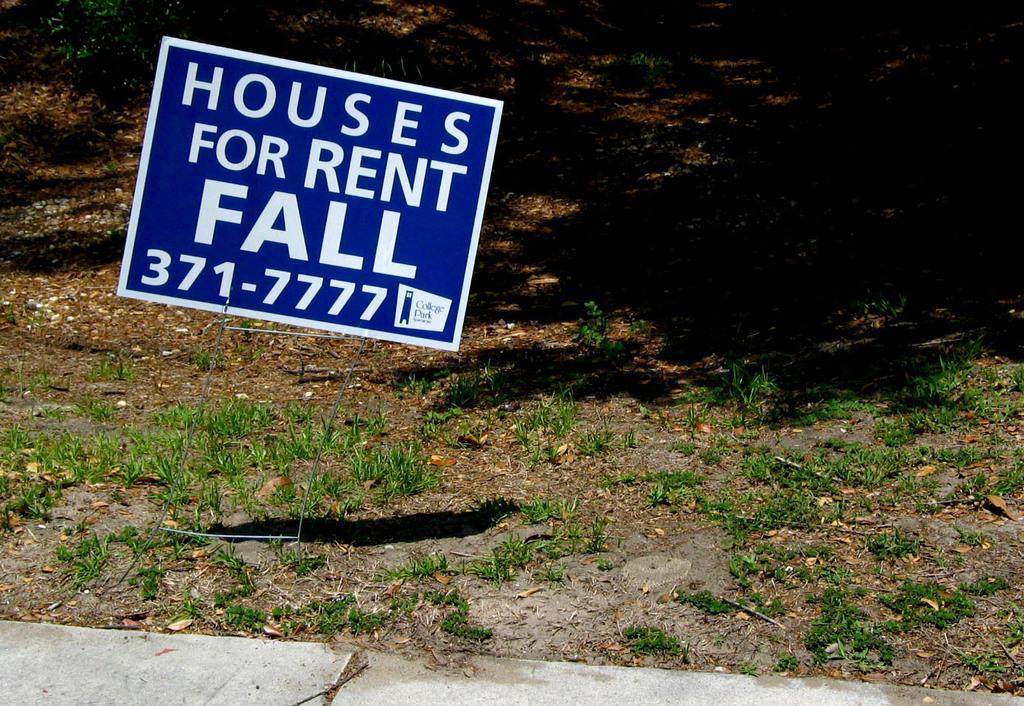Please provide a concise description of this image. In the picture we can see a path with some small grass plants and on it we can see a board and written on it houses for rent fall and some number under it and behind it we can see some muddy path. 